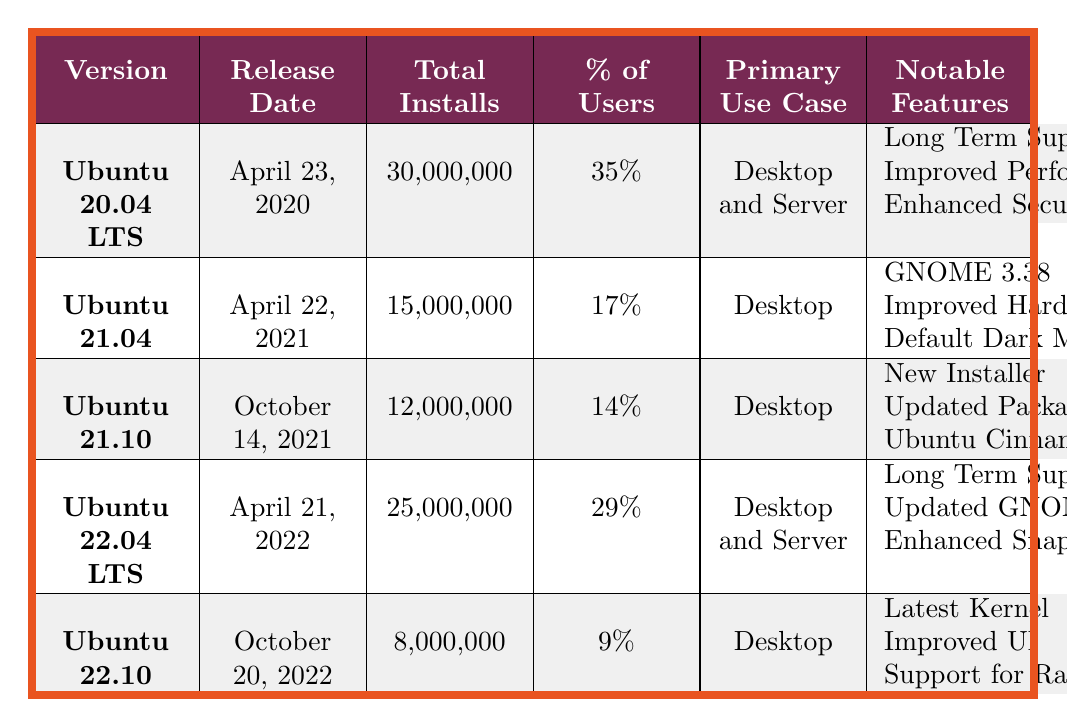What is the primary use case for Ubuntu 22.04 LTS? The table shows that the primary use case for Ubuntu 22.04 LTS is "Desktop and Server".
Answer: Desktop and Server Which version of Ubuntu has the highest total installs? By comparing the total installs for each version in the table, Ubuntu 20.04 LTS has the highest total installs at 30,000,000.
Answer: Ubuntu 20.04 LTS What percentage of users are on Ubuntu 22.10? The table lists the percentage of users for Ubuntu 22.10 as 9%.
Answer: 9% How many total installs do Ubuntu 21.10 and Ubuntu 22.10 have combined? The total installs for Ubuntu 21.10 is 12,000,000 and for Ubuntu 22.10 is 8,000,000. Adding these together gives 12,000,000 + 8,000,000 = 20,000,000.
Answer: 20,000,000 Is there a version of Ubuntu that reached 25 million installs? The table shows that the highest install count is for Ubuntu 20.04 LTS, which has 30,000,000 installs, while Ubuntu 22.04 LTS has 25,000,000 installs. Thus, the statement is true.
Answer: Yes Which version was released most recently, and what notable feature does it have? The most recently released version in the table is Ubuntu 22.10, released on October 20, 2022, with notable features including "Latest Kernel", "Improved UI", and "Support for Raspberry Pi".
Answer: Ubuntu 22.10, Latest Kernel If you were to average the percentage of users across all versions listed, what would it be? To calculate the average percentage of users: (35 + 17 + 14 + 29 + 9) / 5 = 104 / 5 = 20.8.
Answer: 20.8% How does the total installs of Ubuntu 22.04 LTS compare to Ubuntu 21.04? The total installs of Ubuntu 22.04 LTS is 25,000,000, while Ubuntu 21.04 has 15,000,000. The difference is 25,000,000 - 15,000,000 = 10,000,000, showing that 22.04 LTS has 10,000,000 more installs.
Answer: 10,000,000 more What notable feature is common between Ubuntu 20.04 LTS and Ubuntu 22.04 LTS? Both Ubuntu 20.04 LTS and Ubuntu 22.04 LTS have the notable feature of "Long Term Support".
Answer: Long Term Support Which version has the lowest percentage of users, and what is that percentage? The version with the lowest percentage of users is Ubuntu 22.10, which has 9%.
Answer: Ubuntu 22.10, 9% 